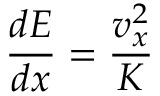Convert formula to latex. <formula><loc_0><loc_0><loc_500><loc_500>{ \frac { d E } { d x } } = { \frac { v _ { x } ^ { 2 } } { K } }</formula> 